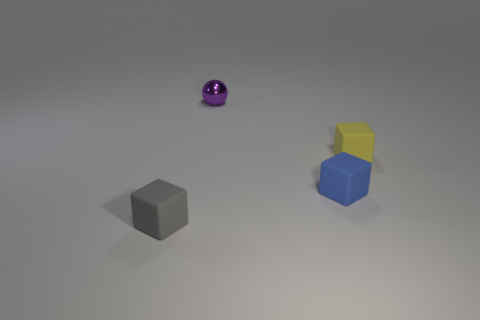The yellow object that is the same material as the blue thing is what size?
Make the answer very short. Small. What is the size of the object that is behind the tiny matte cube that is to the right of the small blue cube?
Your response must be concise. Small. What is the material of the gray cube?
Offer a very short reply. Rubber. Is there a tiny blue block?
Offer a very short reply. Yes. Are there the same number of small blue things that are left of the tiny purple metal ball and brown shiny things?
Offer a terse response. Yes. Is there anything else that has the same material as the small purple sphere?
Make the answer very short. No. How many large things are either spheres or blue cubes?
Make the answer very short. 0. Is the material of the small object that is behind the tiny yellow matte cube the same as the tiny yellow block?
Your answer should be compact. No. What is the material of the tiny thing that is behind the tiny yellow block to the right of the sphere?
Your response must be concise. Metal. How many rubber objects are the same shape as the small metal thing?
Your answer should be very brief. 0. 